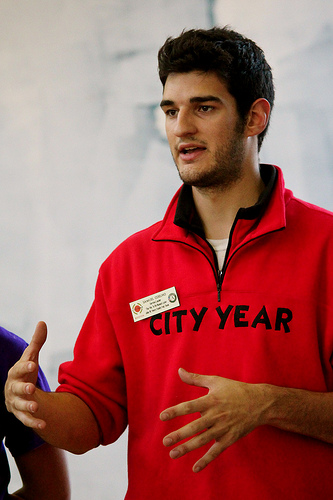<image>
Can you confirm if the collar is next to the shirt? No. The collar is not positioned next to the shirt. They are located in different areas of the scene. 